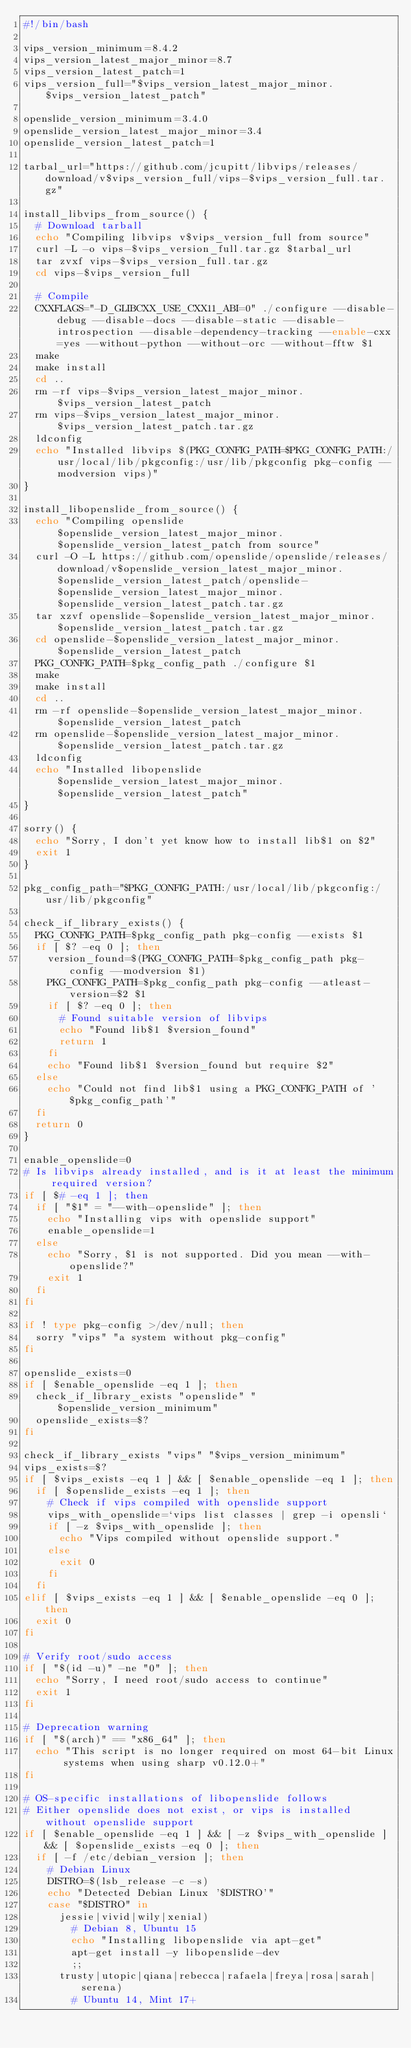<code> <loc_0><loc_0><loc_500><loc_500><_Bash_>#!/bin/bash

vips_version_minimum=8.4.2
vips_version_latest_major_minor=8.7
vips_version_latest_patch=1
vips_version_full="$vips_version_latest_major_minor.$vips_version_latest_patch"

openslide_version_minimum=3.4.0
openslide_version_latest_major_minor=3.4
openslide_version_latest_patch=1

tarbal_url="https://github.com/jcupitt/libvips/releases/download/v$vips_version_full/vips-$vips_version_full.tar.gz"

install_libvips_from_source() {
  # Download tarball
  echo "Compiling libvips v$vips_version_full from source"
  curl -L -o vips-$vips_version_full.tar.gz $tarbal_url
  tar zvxf vips-$vips_version_full.tar.gz
  cd vips-$vips_version_full

  # Compile
  CXXFLAGS="-D_GLIBCXX_USE_CXX11_ABI=0" ./configure --disable-debug --disable-docs --disable-static --disable-introspection --disable-dependency-tracking --enable-cxx=yes --without-python --without-orc --without-fftw $1
  make
  make install
  cd ..
  rm -rf vips-$vips_version_latest_major_minor.$vips_version_latest_patch
  rm vips-$vips_version_latest_major_minor.$vips_version_latest_patch.tar.gz
  ldconfig
  echo "Installed libvips $(PKG_CONFIG_PATH=$PKG_CONFIG_PATH:/usr/local/lib/pkgconfig:/usr/lib/pkgconfig pkg-config --modversion vips)"
}

install_libopenslide_from_source() {
  echo "Compiling openslide $openslide_version_latest_major_minor.$openslide_version_latest_patch from source"
  curl -O -L https://github.com/openslide/openslide/releases/download/v$openslide_version_latest_major_minor.$openslide_version_latest_patch/openslide-$openslide_version_latest_major_minor.$openslide_version_latest_patch.tar.gz
  tar xzvf openslide-$openslide_version_latest_major_minor.$openslide_version_latest_patch.tar.gz
  cd openslide-$openslide_version_latest_major_minor.$openslide_version_latest_patch
  PKG_CONFIG_PATH=$pkg_config_path ./configure $1
  make
  make install
  cd ..
  rm -rf openslide-$openslide_version_latest_major_minor.$openslide_version_latest_patch
  rm openslide-$openslide_version_latest_major_minor.$openslide_version_latest_patch.tar.gz
  ldconfig
  echo "Installed libopenslide $openslide_version_latest_major_minor.$openslide_version_latest_patch"
}

sorry() {
  echo "Sorry, I don't yet know how to install lib$1 on $2"
  exit 1
}

pkg_config_path="$PKG_CONFIG_PATH:/usr/local/lib/pkgconfig:/usr/lib/pkgconfig"

check_if_library_exists() {
  PKG_CONFIG_PATH=$pkg_config_path pkg-config --exists $1
  if [ $? -eq 0 ]; then
    version_found=$(PKG_CONFIG_PATH=$pkg_config_path pkg-config --modversion $1)
    PKG_CONFIG_PATH=$pkg_config_path pkg-config --atleast-version=$2 $1
    if [ $? -eq 0 ]; then
      # Found suitable version of libvips
      echo "Found lib$1 $version_found"
      return 1
    fi
    echo "Found lib$1 $version_found but require $2"
  else
    echo "Could not find lib$1 using a PKG_CONFIG_PATH of '$pkg_config_path'"
  fi
  return 0
}

enable_openslide=0
# Is libvips already installed, and is it at least the minimum required version?
if [ $# -eq 1 ]; then
  if [ "$1" = "--with-openslide" ]; then
    echo "Installing vips with openslide support"
    enable_openslide=1
  else
    echo "Sorry, $1 is not supported. Did you mean --with-openslide?"
    exit 1
  fi
fi

if ! type pkg-config >/dev/null; then
  sorry "vips" "a system without pkg-config"
fi

openslide_exists=0
if [ $enable_openslide -eq 1 ]; then
  check_if_library_exists "openslide" "$openslide_version_minimum"
  openslide_exists=$?
fi

check_if_library_exists "vips" "$vips_version_minimum"
vips_exists=$?
if [ $vips_exists -eq 1 ] && [ $enable_openslide -eq 1 ]; then
  if [ $openslide_exists -eq 1 ]; then
    # Check if vips compiled with openslide support
    vips_with_openslide=`vips list classes | grep -i opensli`
    if [ -z $vips_with_openslide ]; then
      echo "Vips compiled without openslide support."
    else
      exit 0
    fi
  fi
elif [ $vips_exists -eq 1 ] && [ $enable_openslide -eq 0 ]; then
  exit 0
fi

# Verify root/sudo access
if [ "$(id -u)" -ne "0" ]; then
  echo "Sorry, I need root/sudo access to continue"
  exit 1
fi

# Deprecation warning
if [ "$(arch)" == "x86_64" ]; then
  echo "This script is no longer required on most 64-bit Linux systems when using sharp v0.12.0+"
fi

# OS-specific installations of libopenslide follows
# Either openslide does not exist, or vips is installed without openslide support
if [ $enable_openslide -eq 1 ] && [ -z $vips_with_openslide ] && [ $openslide_exists -eq 0 ]; then
  if [ -f /etc/debian_version ]; then
    # Debian Linux
    DISTRO=$(lsb_release -c -s)
    echo "Detected Debian Linux '$DISTRO'"
    case "$DISTRO" in
      jessie|vivid|wily|xenial)
        # Debian 8, Ubuntu 15
        echo "Installing libopenslide via apt-get"
        apt-get install -y libopenslide-dev
        ;;
      trusty|utopic|qiana|rebecca|rafaela|freya|rosa|sarah|serena)
        # Ubuntu 14, Mint 17+</code> 